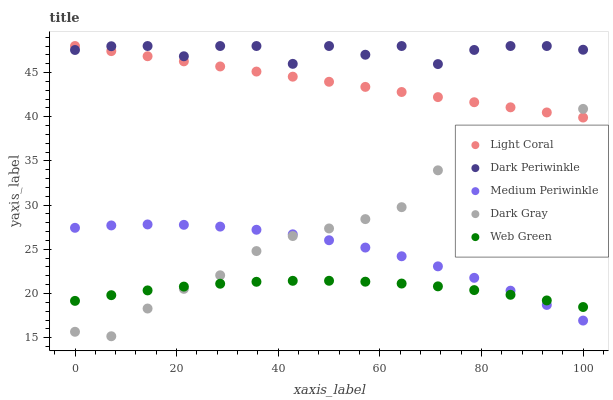Does Web Green have the minimum area under the curve?
Answer yes or no. Yes. Does Dark Periwinkle have the maximum area under the curve?
Answer yes or no. Yes. Does Dark Gray have the minimum area under the curve?
Answer yes or no. No. Does Dark Gray have the maximum area under the curve?
Answer yes or no. No. Is Light Coral the smoothest?
Answer yes or no. Yes. Is Dark Periwinkle the roughest?
Answer yes or no. Yes. Is Dark Gray the smoothest?
Answer yes or no. No. Is Dark Gray the roughest?
Answer yes or no. No. Does Dark Gray have the lowest value?
Answer yes or no. Yes. Does Medium Periwinkle have the lowest value?
Answer yes or no. No. Does Dark Periwinkle have the highest value?
Answer yes or no. Yes. Does Dark Gray have the highest value?
Answer yes or no. No. Is Web Green less than Dark Periwinkle?
Answer yes or no. Yes. Is Light Coral greater than Medium Periwinkle?
Answer yes or no. Yes. Does Medium Periwinkle intersect Web Green?
Answer yes or no. Yes. Is Medium Periwinkle less than Web Green?
Answer yes or no. No. Is Medium Periwinkle greater than Web Green?
Answer yes or no. No. Does Web Green intersect Dark Periwinkle?
Answer yes or no. No. 